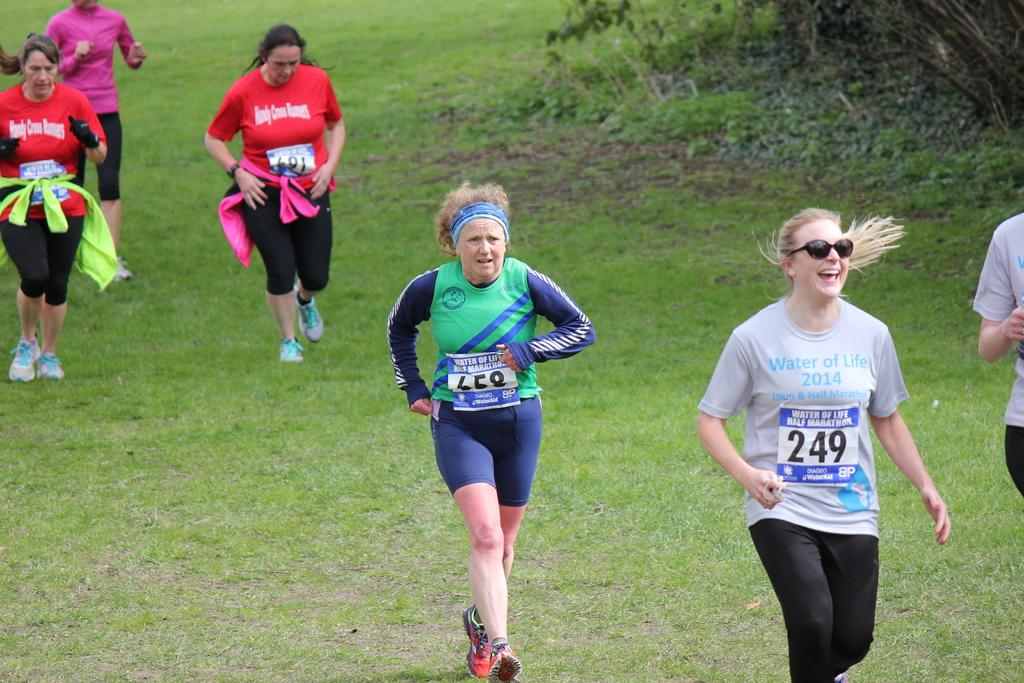What are the persons in the image doing? The persons in the image are running. What can be seen in the background of the image? There is grass in the background of the image. Where are the plants located in the image? The plants are in the top right corner of the image. What angle does the burst of light take in the image? There is no burst of light present in the image. 